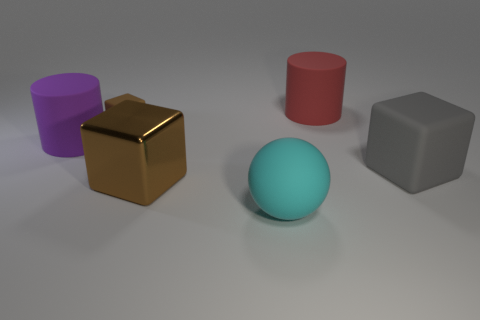Add 4 cyan cylinders. How many objects exist? 10 Subtract all cylinders. How many objects are left? 4 Subtract 0 red cubes. How many objects are left? 6 Subtract all tiny red metallic spheres. Subtract all big things. How many objects are left? 1 Add 5 matte blocks. How many matte blocks are left? 7 Add 3 big cyan spheres. How many big cyan spheres exist? 4 